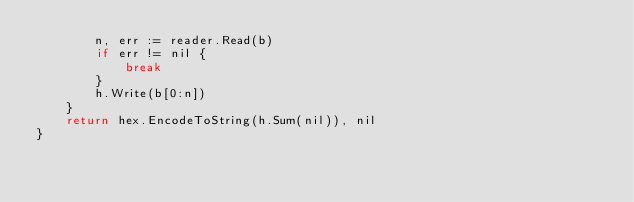Convert code to text. <code><loc_0><loc_0><loc_500><loc_500><_Go_>		n, err := reader.Read(b)
		if err != nil {
			break
		}
		h.Write(b[0:n])
	}
	return hex.EncodeToString(h.Sum(nil)), nil
}
</code> 